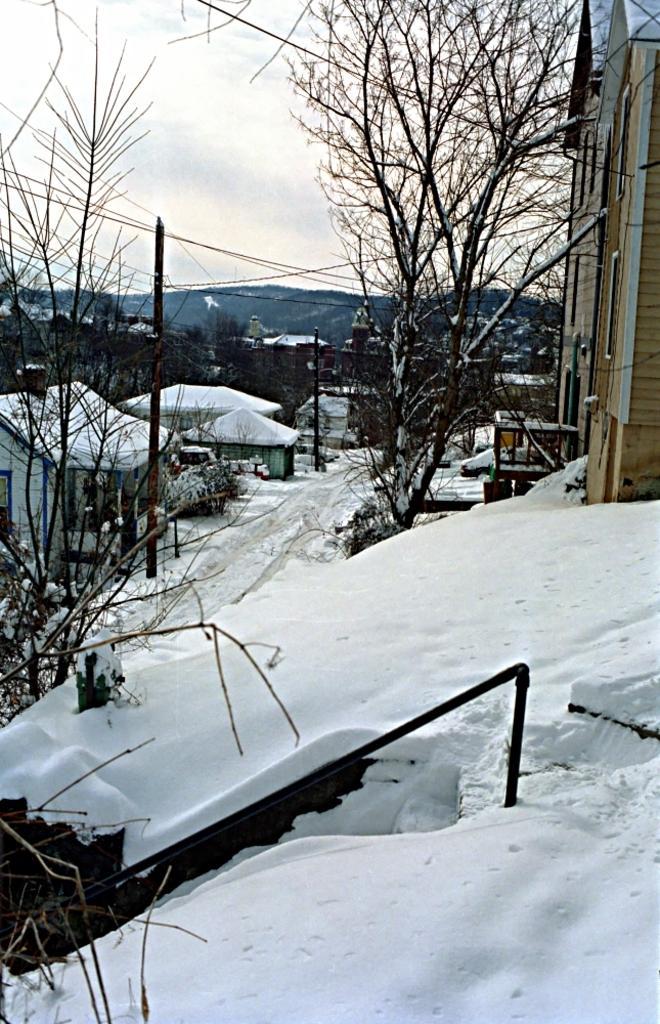Describe this image in one or two sentences. In front of the image there is a metal rod, dried branches of trees, metal pipe on the snow surface, behind that there are trees and buildings covered with snow, on top of the image there are cables passing through, in the background of the image there are mountains, at the top of the image there are clouds in the sky. 